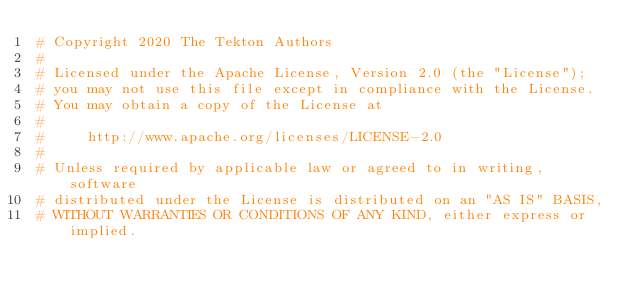Convert code to text. <code><loc_0><loc_0><loc_500><loc_500><_Python_># Copyright 2020 The Tekton Authors
#
# Licensed under the Apache License, Version 2.0 (the "License");
# you may not use this file except in compliance with the License.
# You may obtain a copy of the License at
#
#     http://www.apache.org/licenses/LICENSE-2.0
#
# Unless required by applicable law or agreed to in writing, software
# distributed under the License is distributed on an "AS IS" BASIS,
# WITHOUT WARRANTIES OR CONDITIONS OF ANY KIND, either express or implied.</code> 